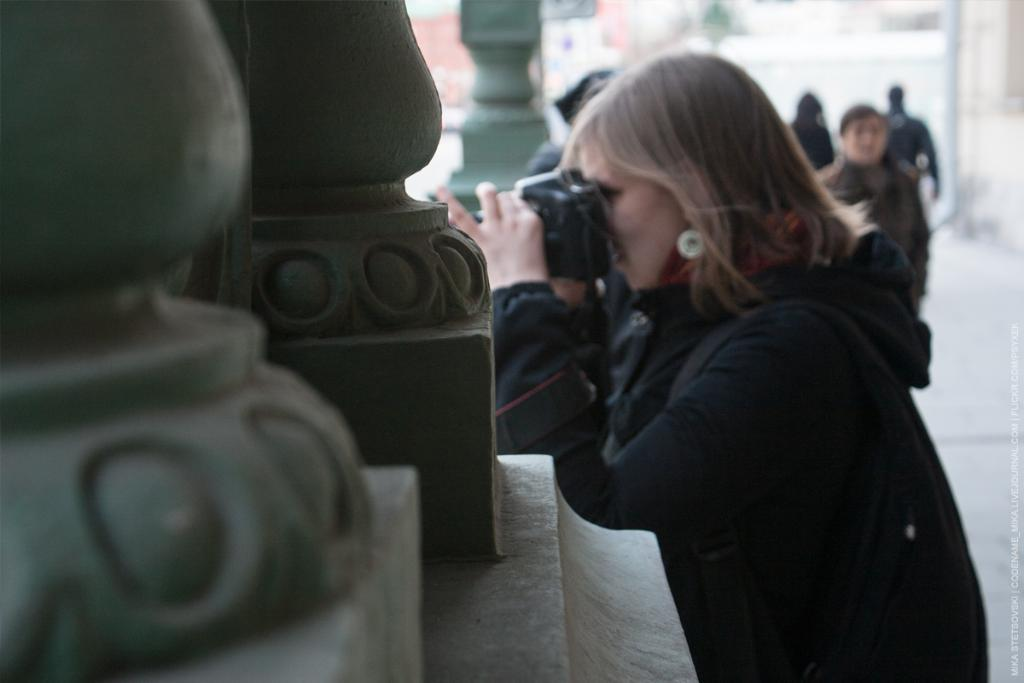Who is the main subject in the image? There is a woman in the image. What is the woman holding in the image? The woman is holding a camera. What architectural features can be seen in the image? There are pillars in the image. What can be seen in the background of the image? There are people in the background of the image, and they are on a path. What type of plant is growing on the woman's head in the image? There is no plant growing on the woman's head in the image. Can you hear the woman speaking in the image? The image is silent, so we cannot hear the woman speaking. 